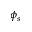<formula> <loc_0><loc_0><loc_500><loc_500>\phi _ { s }</formula> 